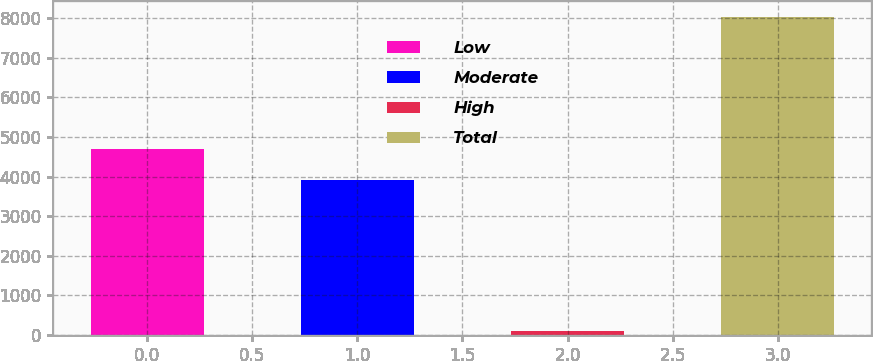<chart> <loc_0><loc_0><loc_500><loc_500><bar_chart><fcel>Low<fcel>Moderate<fcel>High<fcel>Total<nl><fcel>4702.6<fcel>3909<fcel>97<fcel>8033<nl></chart> 